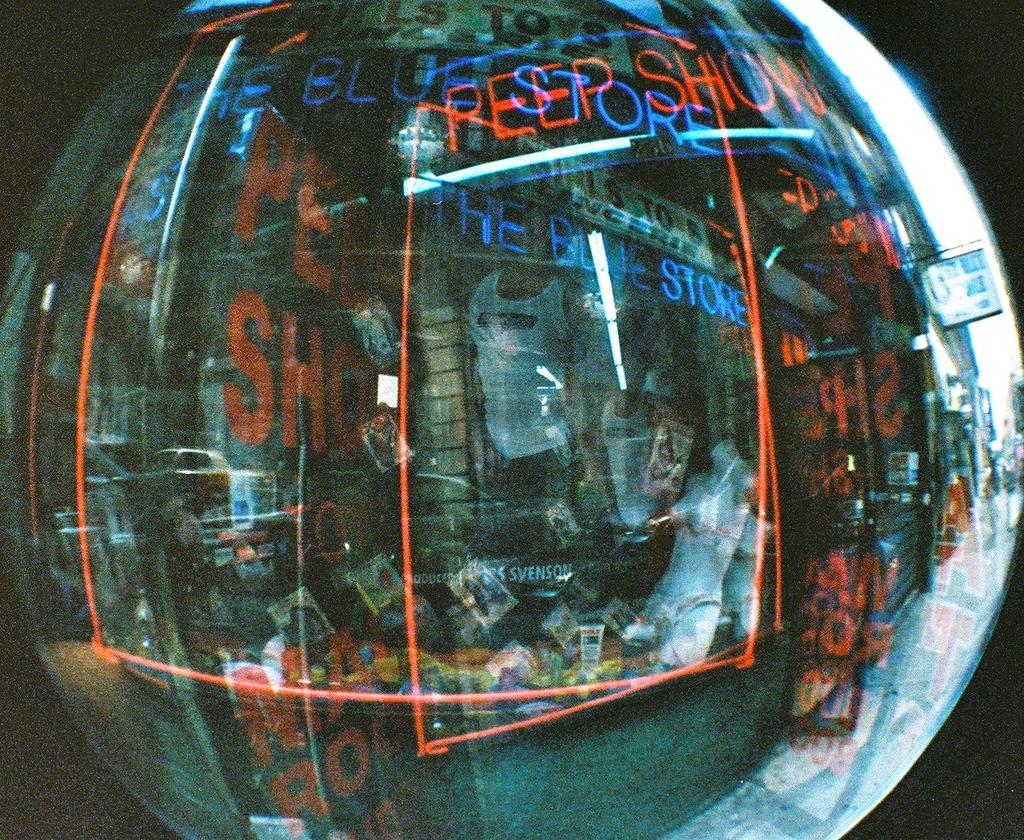What is the main object in the image? There is a round globe-like object in the image. What can be observed on the surface of the object? The object has reflections of lights and text visible on it. Who or what can be seen reflected in the object? There are people reflected in the object. How would you describe the overall appearance of the image? The background of the image is dark. How does the nut contribute to the increase in the map's accuracy in the image? There is no nut or map present in the image; it features a round globe-like object with reflections, text, and people reflected in it. 